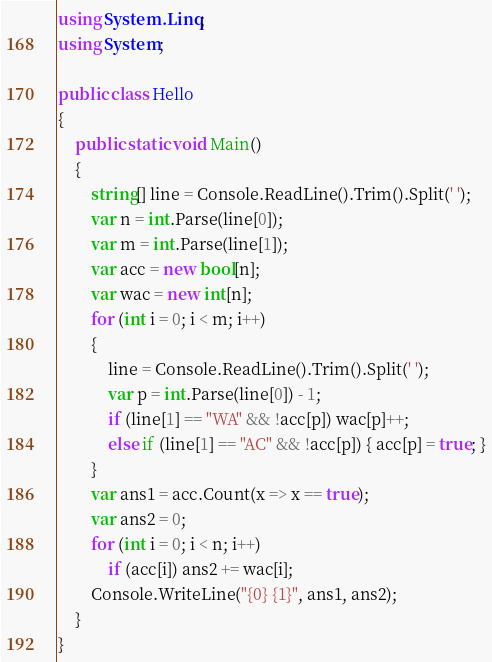Convert code to text. <code><loc_0><loc_0><loc_500><loc_500><_C#_>using System.Linq;
using System;

public class Hello
{
    public static void Main()
    {
        string[] line = Console.ReadLine().Trim().Split(' ');
        var n = int.Parse(line[0]);
        var m = int.Parse(line[1]);
        var acc = new bool[n];
        var wac = new int[n];
        for (int i = 0; i < m; i++)
        {
            line = Console.ReadLine().Trim().Split(' ');
            var p = int.Parse(line[0]) - 1;
            if (line[1] == "WA" && !acc[p]) wac[p]++;
            else if (line[1] == "AC" && !acc[p]) { acc[p] = true; }
        }
        var ans1 = acc.Count(x => x == true);
        var ans2 = 0;
        for (int i = 0; i < n; i++)
            if (acc[i]) ans2 += wac[i];
        Console.WriteLine("{0} {1}", ans1, ans2);
    }
}
</code> 